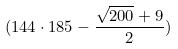Convert formula to latex. <formula><loc_0><loc_0><loc_500><loc_500>( 1 4 4 \cdot 1 8 5 - \frac { \sqrt { 2 0 0 } + 9 } { 2 } )</formula> 